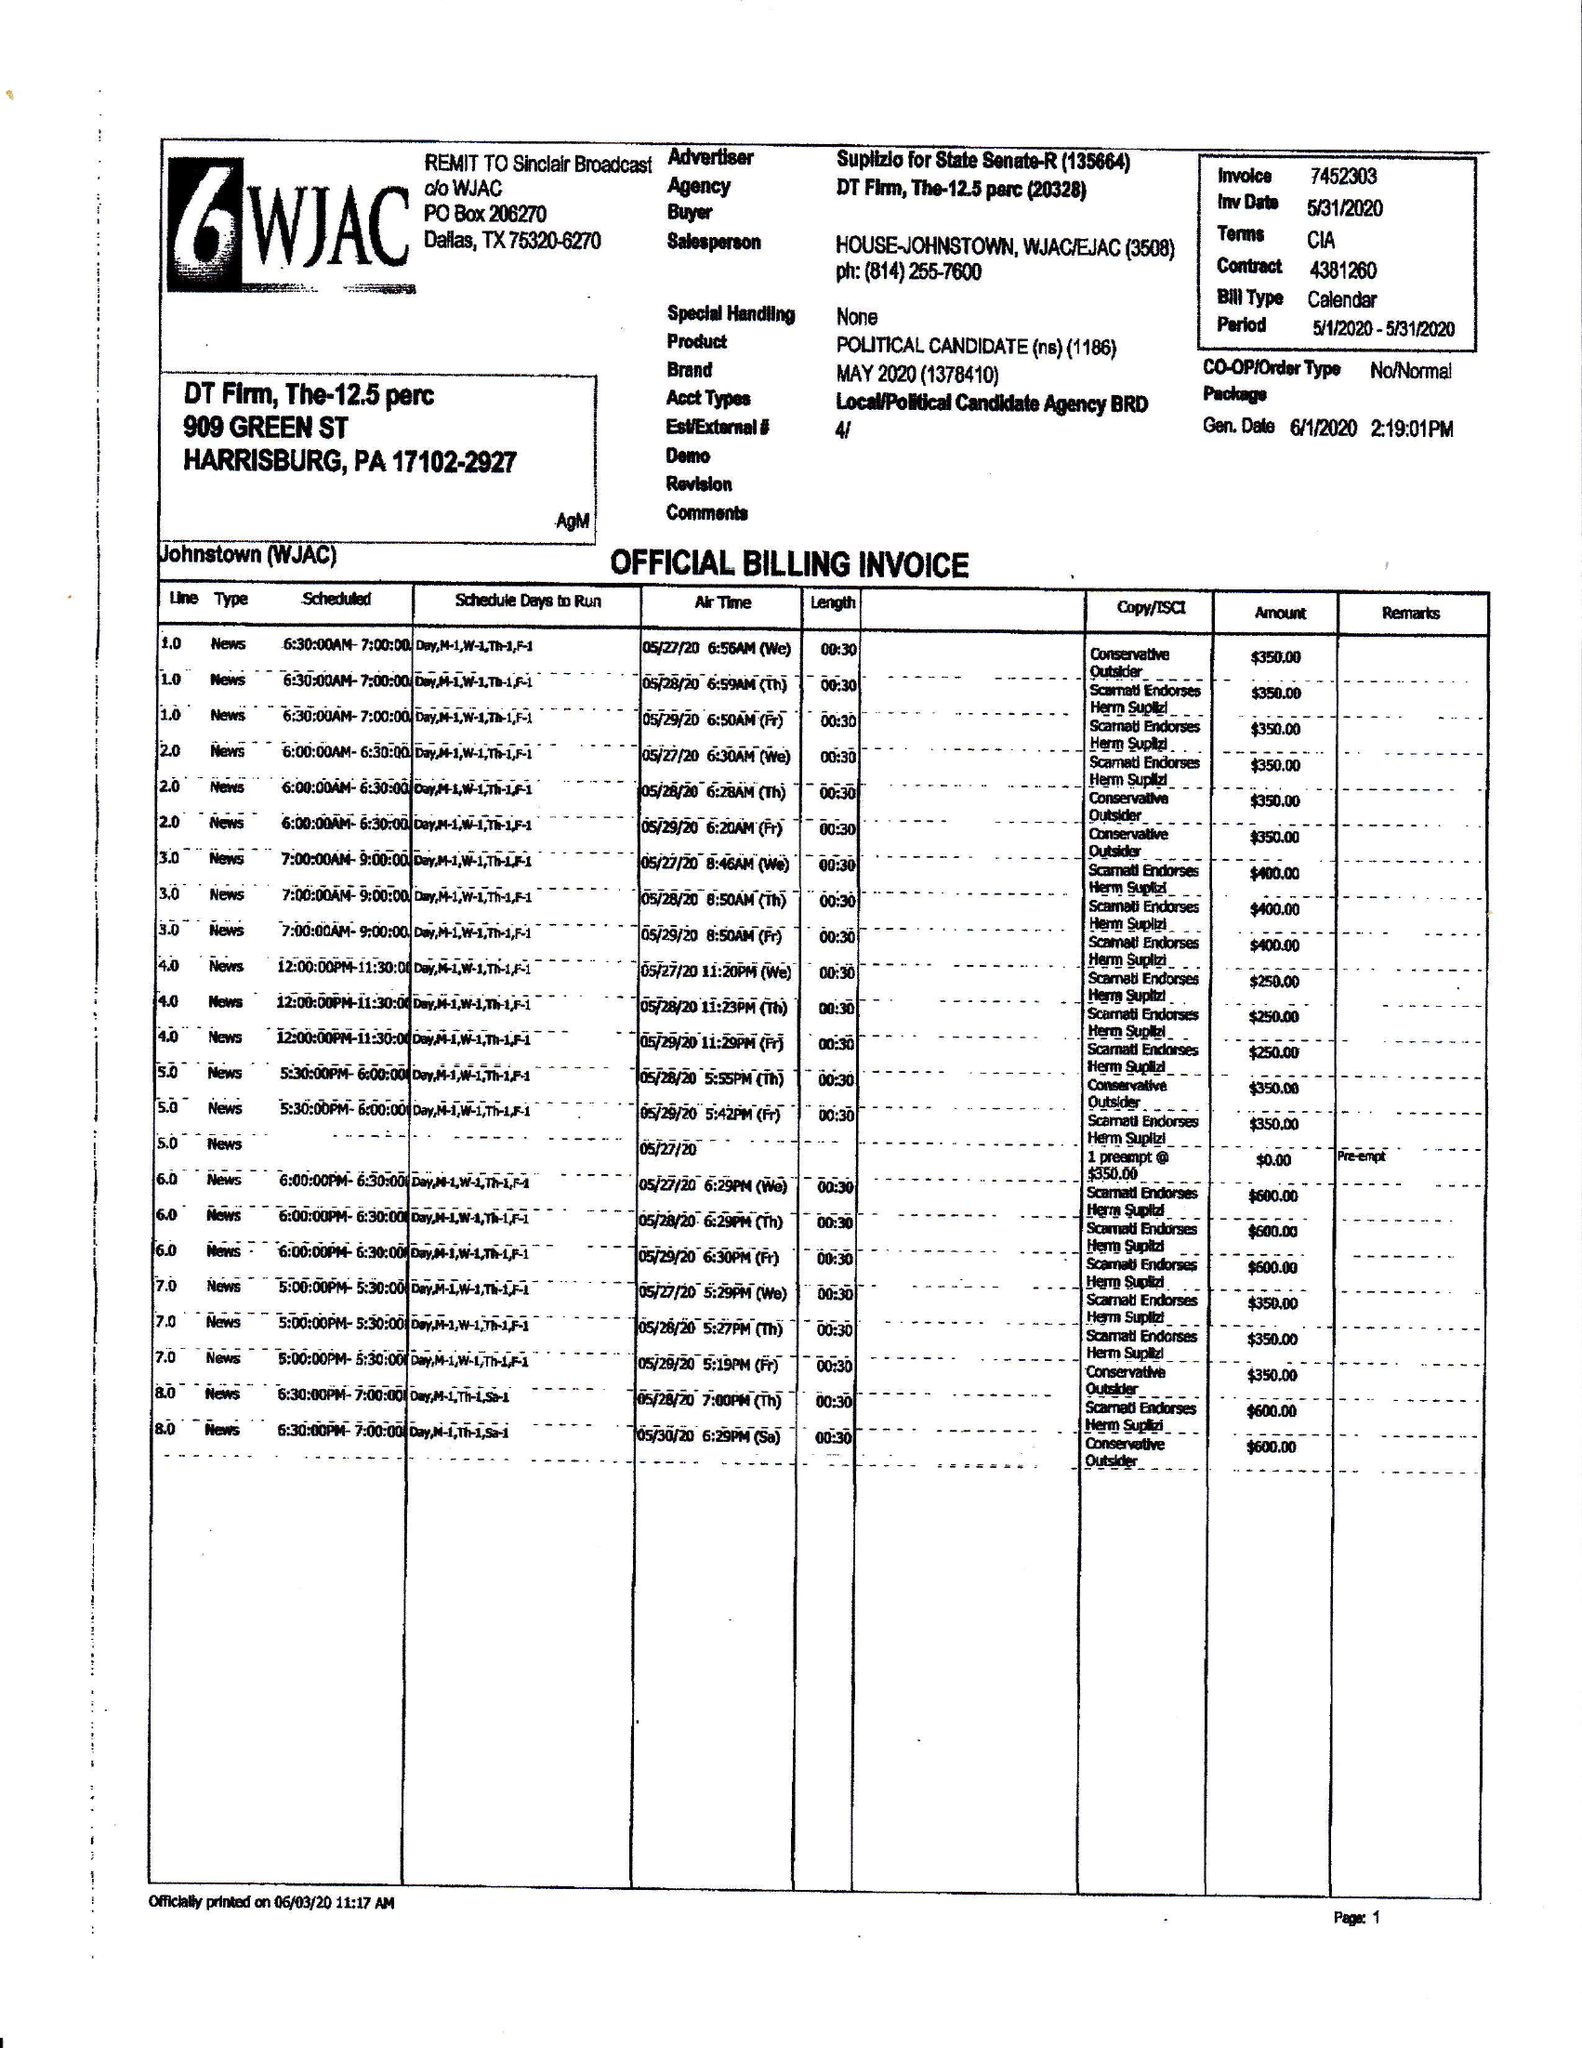What is the value for the contract_num?
Answer the question using a single word or phrase. 4381260 